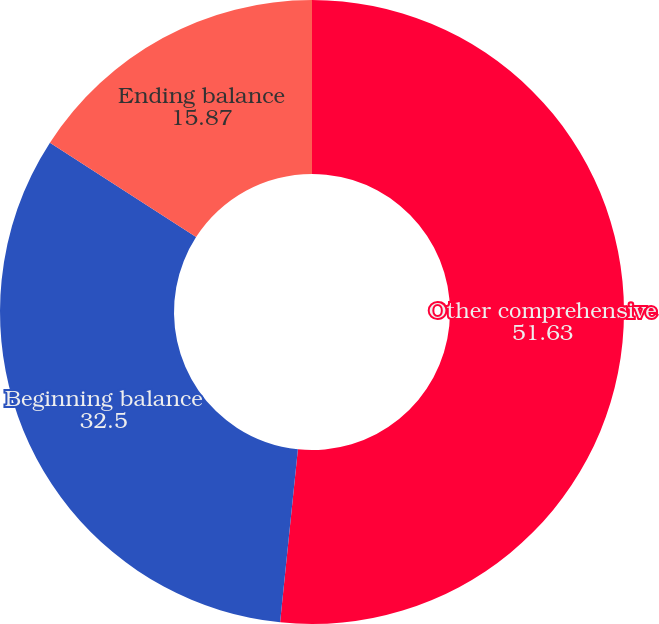Convert chart. <chart><loc_0><loc_0><loc_500><loc_500><pie_chart><fcel>Other comprehensive<fcel>Beginning balance<fcel>Ending balance<nl><fcel>51.63%<fcel>32.5%<fcel>15.87%<nl></chart> 